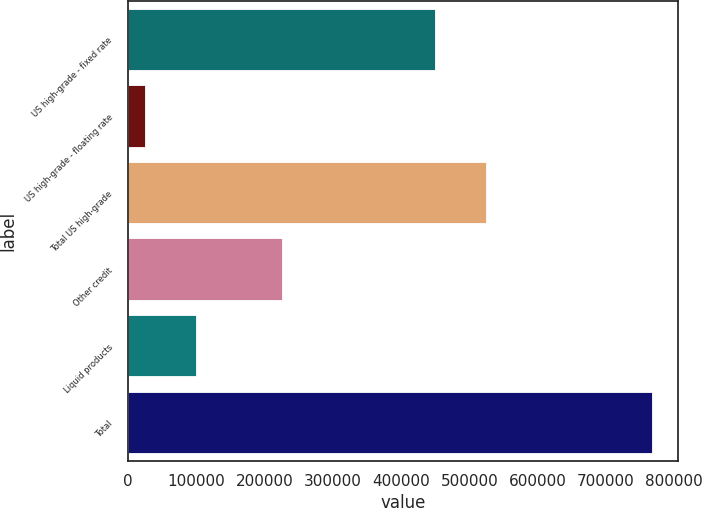<chart> <loc_0><loc_0><loc_500><loc_500><bar_chart><fcel>US high-grade - fixed rate<fcel>US high-grade - floating rate<fcel>Total US high-grade<fcel>Other credit<fcel>Liquid products<fcel>Total<nl><fcel>450139<fcel>25231<fcel>524312<fcel>226033<fcel>99404<fcel>766961<nl></chart> 